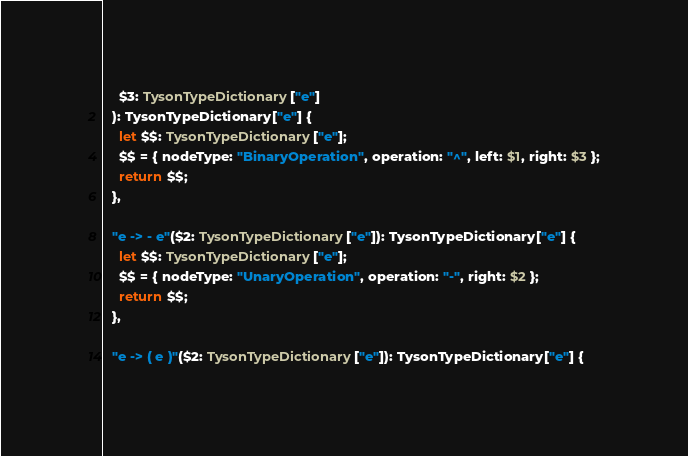Convert code to text. <code><loc_0><loc_0><loc_500><loc_500><_TypeScript_>    $3: TysonTypeDictionary["e"]
  ): TysonTypeDictionary["e"] {
    let $$: TysonTypeDictionary["e"];
    $$ = { nodeType: "BinaryOperation", operation: "^", left: $1, right: $3 };
    return $$;
  },

  "e -> - e"($2: TysonTypeDictionary["e"]): TysonTypeDictionary["e"] {
    let $$: TysonTypeDictionary["e"];
    $$ = { nodeType: "UnaryOperation", operation: "-", right: $2 };
    return $$;
  },

  "e -> ( e )"($2: TysonTypeDictionary["e"]): TysonTypeDictionary["e"] {</code> 